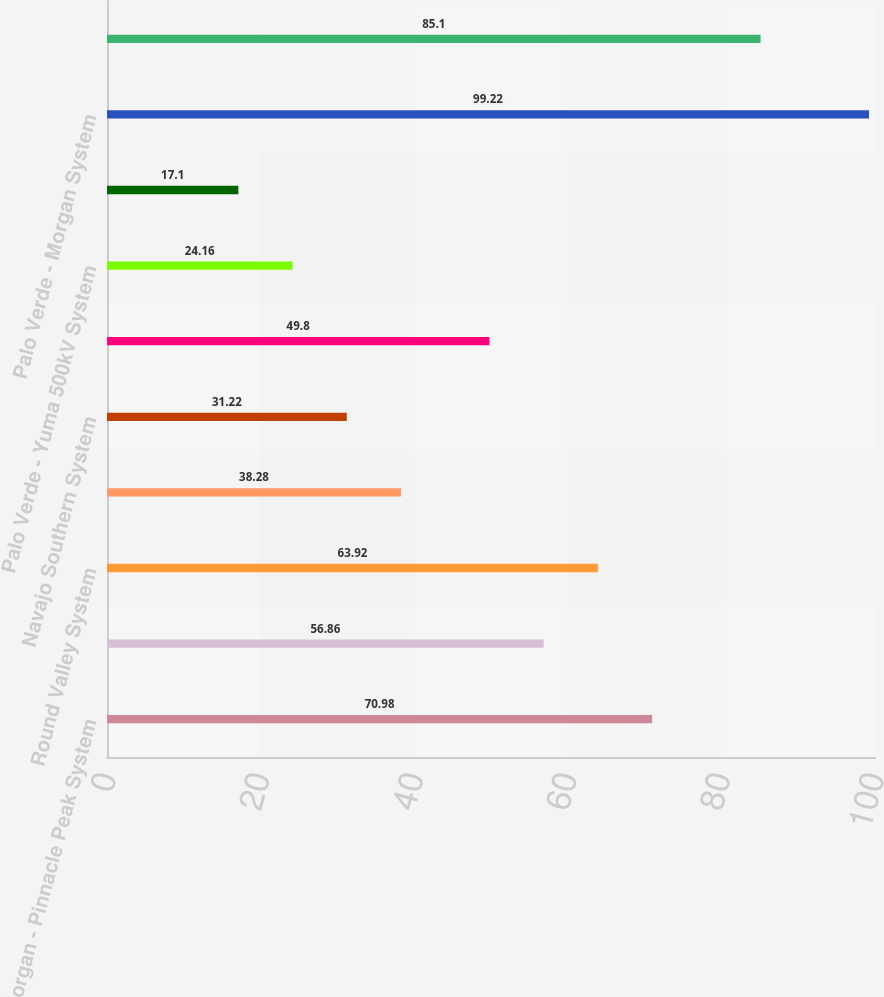<chart> <loc_0><loc_0><loc_500><loc_500><bar_chart><fcel>Morgan - Pinnacle Peak System<fcel>Palo Verde - Estrella 500kV<fcel>Round Valley System<fcel>ANPP 500kV System<fcel>Navajo Southern System<fcel>Four Corners Switchyards<fcel>Palo Verde - Yuma 500kV System<fcel>Phoenix - Mead System<fcel>Palo Verde - Morgan System<fcel>Hassayampa - North Gila System<nl><fcel>70.98<fcel>56.86<fcel>63.92<fcel>38.28<fcel>31.22<fcel>49.8<fcel>24.16<fcel>17.1<fcel>99.22<fcel>85.1<nl></chart> 